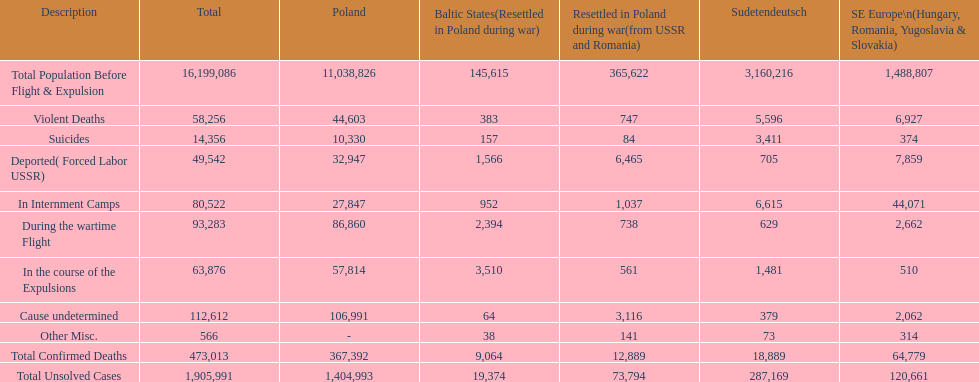Which region had the least total of unsolved cases? Baltic States(Resettled in Poland during war). 